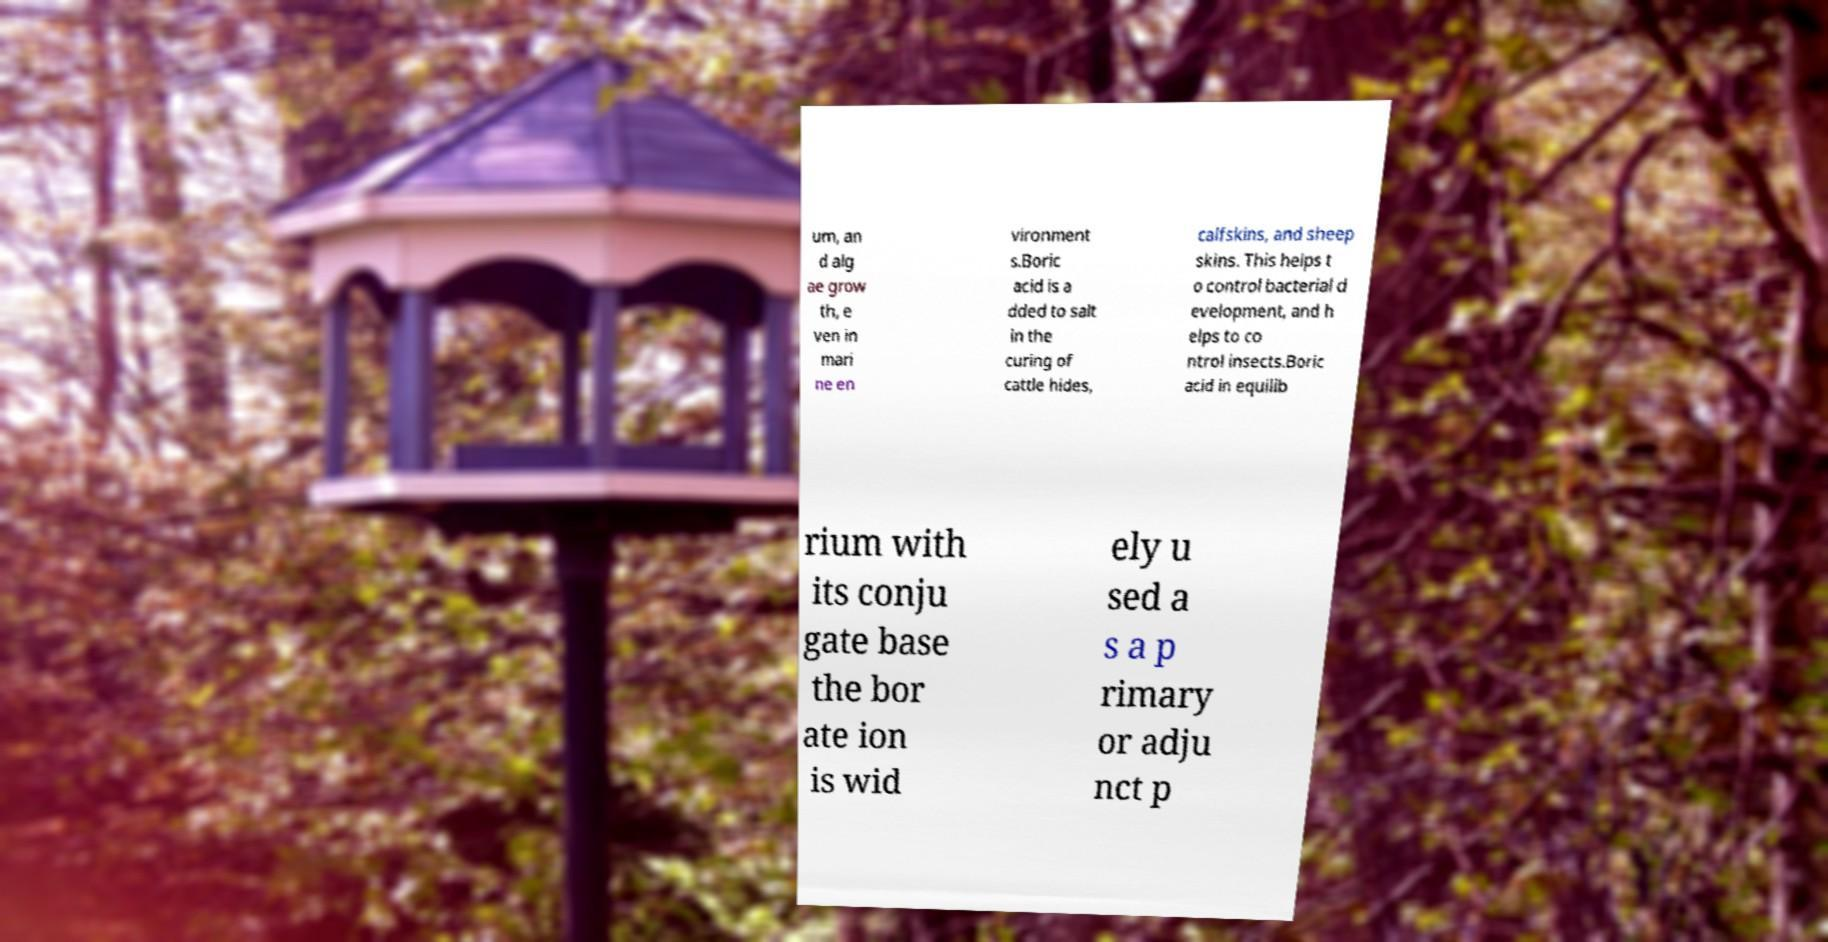Could you assist in decoding the text presented in this image and type it out clearly? um, an d alg ae grow th, e ven in mari ne en vironment s.Boric acid is a dded to salt in the curing of cattle hides, calfskins, and sheep skins. This helps t o control bacterial d evelopment, and h elps to co ntrol insects.Boric acid in equilib rium with its conju gate base the bor ate ion is wid ely u sed a s a p rimary or adju nct p 